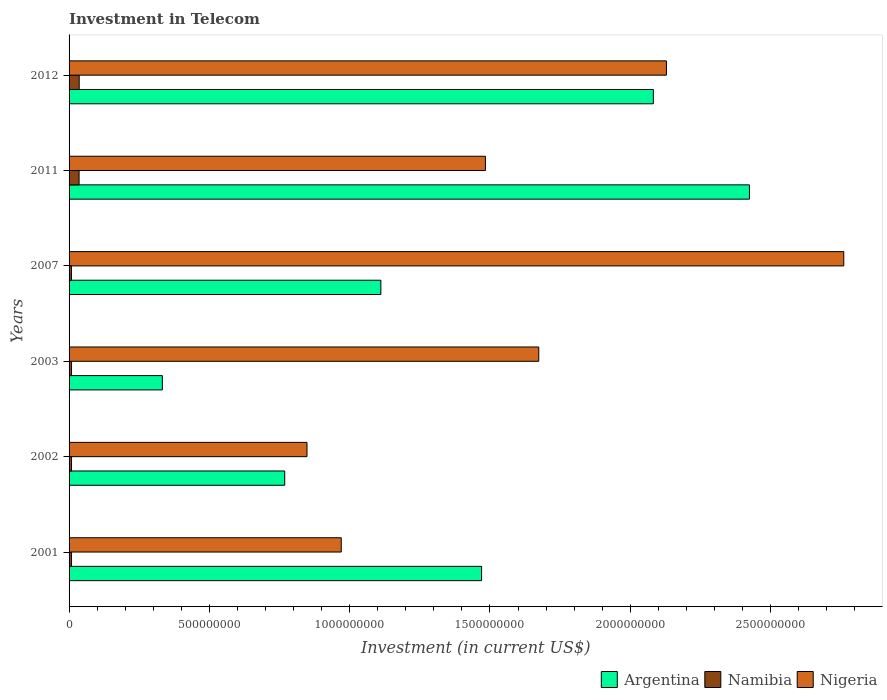How many groups of bars are there?
Ensure brevity in your answer.  6. How many bars are there on the 5th tick from the top?
Offer a very short reply. 3. What is the amount invested in telecom in Namibia in 2002?
Provide a short and direct response. 8.75e+06. Across all years, what is the maximum amount invested in telecom in Argentina?
Keep it short and to the point. 2.42e+09. Across all years, what is the minimum amount invested in telecom in Namibia?
Give a very brief answer. 8.50e+06. In which year was the amount invested in telecom in Nigeria minimum?
Ensure brevity in your answer.  2002. What is the total amount invested in telecom in Argentina in the graph?
Keep it short and to the point. 8.19e+09. What is the difference between the amount invested in telecom in Argentina in 2003 and that in 2007?
Give a very brief answer. -7.79e+08. What is the difference between the amount invested in telecom in Nigeria in 2011 and the amount invested in telecom in Namibia in 2001?
Ensure brevity in your answer.  1.48e+09. What is the average amount invested in telecom in Nigeria per year?
Your answer should be compact. 1.64e+09. In the year 2002, what is the difference between the amount invested in telecom in Argentina and amount invested in telecom in Namibia?
Make the answer very short. 7.60e+08. What is the ratio of the amount invested in telecom in Argentina in 2001 to that in 2012?
Offer a very short reply. 0.71. Is the difference between the amount invested in telecom in Argentina in 2003 and 2012 greater than the difference between the amount invested in telecom in Namibia in 2003 and 2012?
Offer a terse response. No. What is the difference between the highest and the second highest amount invested in telecom in Namibia?
Provide a succinct answer. 4.00e+05. What is the difference between the highest and the lowest amount invested in telecom in Namibia?
Your answer should be very brief. 2.76e+07. In how many years, is the amount invested in telecom in Nigeria greater than the average amount invested in telecom in Nigeria taken over all years?
Give a very brief answer. 3. Is the sum of the amount invested in telecom in Nigeria in 2001 and 2007 greater than the maximum amount invested in telecom in Namibia across all years?
Your answer should be compact. Yes. What does the 2nd bar from the top in 2012 represents?
Make the answer very short. Namibia. Are all the bars in the graph horizontal?
Your response must be concise. Yes. How many years are there in the graph?
Make the answer very short. 6. Does the graph contain grids?
Offer a terse response. No. How many legend labels are there?
Keep it short and to the point. 3. How are the legend labels stacked?
Your answer should be compact. Horizontal. What is the title of the graph?
Your answer should be compact. Investment in Telecom. What is the label or title of the X-axis?
Offer a very short reply. Investment (in current US$). What is the label or title of the Y-axis?
Ensure brevity in your answer.  Years. What is the Investment (in current US$) of Argentina in 2001?
Your answer should be compact. 1.47e+09. What is the Investment (in current US$) in Namibia in 2001?
Offer a very short reply. 8.75e+06. What is the Investment (in current US$) in Nigeria in 2001?
Provide a succinct answer. 9.70e+08. What is the Investment (in current US$) of Argentina in 2002?
Provide a short and direct response. 7.69e+08. What is the Investment (in current US$) in Namibia in 2002?
Your answer should be very brief. 8.75e+06. What is the Investment (in current US$) of Nigeria in 2002?
Your answer should be compact. 8.48e+08. What is the Investment (in current US$) of Argentina in 2003?
Provide a succinct answer. 3.32e+08. What is the Investment (in current US$) of Namibia in 2003?
Ensure brevity in your answer.  8.75e+06. What is the Investment (in current US$) in Nigeria in 2003?
Offer a terse response. 1.67e+09. What is the Investment (in current US$) of Argentina in 2007?
Keep it short and to the point. 1.11e+09. What is the Investment (in current US$) of Namibia in 2007?
Offer a terse response. 8.50e+06. What is the Investment (in current US$) of Nigeria in 2007?
Make the answer very short. 2.76e+09. What is the Investment (in current US$) of Argentina in 2011?
Your response must be concise. 2.42e+09. What is the Investment (in current US$) of Namibia in 2011?
Keep it short and to the point. 3.57e+07. What is the Investment (in current US$) in Nigeria in 2011?
Provide a short and direct response. 1.48e+09. What is the Investment (in current US$) in Argentina in 2012?
Make the answer very short. 2.08e+09. What is the Investment (in current US$) of Namibia in 2012?
Make the answer very short. 3.61e+07. What is the Investment (in current US$) of Nigeria in 2012?
Keep it short and to the point. 2.13e+09. Across all years, what is the maximum Investment (in current US$) in Argentina?
Make the answer very short. 2.42e+09. Across all years, what is the maximum Investment (in current US$) of Namibia?
Offer a terse response. 3.61e+07. Across all years, what is the maximum Investment (in current US$) in Nigeria?
Keep it short and to the point. 2.76e+09. Across all years, what is the minimum Investment (in current US$) in Argentina?
Provide a short and direct response. 3.32e+08. Across all years, what is the minimum Investment (in current US$) of Namibia?
Your response must be concise. 8.50e+06. Across all years, what is the minimum Investment (in current US$) in Nigeria?
Provide a short and direct response. 8.48e+08. What is the total Investment (in current US$) of Argentina in the graph?
Your response must be concise. 8.19e+09. What is the total Investment (in current US$) of Namibia in the graph?
Make the answer very short. 1.07e+08. What is the total Investment (in current US$) in Nigeria in the graph?
Your answer should be very brief. 9.87e+09. What is the difference between the Investment (in current US$) in Argentina in 2001 and that in 2002?
Ensure brevity in your answer.  7.02e+08. What is the difference between the Investment (in current US$) in Namibia in 2001 and that in 2002?
Ensure brevity in your answer.  0. What is the difference between the Investment (in current US$) of Nigeria in 2001 and that in 2002?
Your answer should be compact. 1.22e+08. What is the difference between the Investment (in current US$) of Argentina in 2001 and that in 2003?
Offer a very short reply. 1.14e+09. What is the difference between the Investment (in current US$) of Namibia in 2001 and that in 2003?
Give a very brief answer. 0. What is the difference between the Investment (in current US$) of Nigeria in 2001 and that in 2003?
Your response must be concise. -7.04e+08. What is the difference between the Investment (in current US$) in Argentina in 2001 and that in 2007?
Offer a terse response. 3.59e+08. What is the difference between the Investment (in current US$) in Nigeria in 2001 and that in 2007?
Your response must be concise. -1.79e+09. What is the difference between the Investment (in current US$) in Argentina in 2001 and that in 2011?
Provide a short and direct response. -9.55e+08. What is the difference between the Investment (in current US$) of Namibia in 2001 and that in 2011?
Provide a succinct answer. -2.70e+07. What is the difference between the Investment (in current US$) of Nigeria in 2001 and that in 2011?
Provide a succinct answer. -5.14e+08. What is the difference between the Investment (in current US$) in Argentina in 2001 and that in 2012?
Provide a succinct answer. -6.12e+08. What is the difference between the Investment (in current US$) of Namibia in 2001 and that in 2012?
Make the answer very short. -2.74e+07. What is the difference between the Investment (in current US$) in Nigeria in 2001 and that in 2012?
Keep it short and to the point. -1.16e+09. What is the difference between the Investment (in current US$) in Argentina in 2002 and that in 2003?
Offer a very short reply. 4.36e+08. What is the difference between the Investment (in current US$) of Nigeria in 2002 and that in 2003?
Your response must be concise. -8.26e+08. What is the difference between the Investment (in current US$) of Argentina in 2002 and that in 2007?
Your answer should be compact. -3.43e+08. What is the difference between the Investment (in current US$) in Namibia in 2002 and that in 2007?
Keep it short and to the point. 2.50e+05. What is the difference between the Investment (in current US$) of Nigeria in 2002 and that in 2007?
Provide a short and direct response. -1.91e+09. What is the difference between the Investment (in current US$) of Argentina in 2002 and that in 2011?
Offer a terse response. -1.66e+09. What is the difference between the Investment (in current US$) in Namibia in 2002 and that in 2011?
Make the answer very short. -2.70e+07. What is the difference between the Investment (in current US$) of Nigeria in 2002 and that in 2011?
Provide a succinct answer. -6.36e+08. What is the difference between the Investment (in current US$) of Argentina in 2002 and that in 2012?
Give a very brief answer. -1.31e+09. What is the difference between the Investment (in current US$) of Namibia in 2002 and that in 2012?
Offer a terse response. -2.74e+07. What is the difference between the Investment (in current US$) in Nigeria in 2002 and that in 2012?
Ensure brevity in your answer.  -1.28e+09. What is the difference between the Investment (in current US$) of Argentina in 2003 and that in 2007?
Offer a very short reply. -7.79e+08. What is the difference between the Investment (in current US$) of Nigeria in 2003 and that in 2007?
Provide a succinct answer. -1.09e+09. What is the difference between the Investment (in current US$) of Argentina in 2003 and that in 2011?
Ensure brevity in your answer.  -2.09e+09. What is the difference between the Investment (in current US$) in Namibia in 2003 and that in 2011?
Keep it short and to the point. -2.70e+07. What is the difference between the Investment (in current US$) of Nigeria in 2003 and that in 2011?
Keep it short and to the point. 1.90e+08. What is the difference between the Investment (in current US$) of Argentina in 2003 and that in 2012?
Your answer should be very brief. -1.75e+09. What is the difference between the Investment (in current US$) in Namibia in 2003 and that in 2012?
Your response must be concise. -2.74e+07. What is the difference between the Investment (in current US$) in Nigeria in 2003 and that in 2012?
Keep it short and to the point. -4.55e+08. What is the difference between the Investment (in current US$) of Argentina in 2007 and that in 2011?
Give a very brief answer. -1.31e+09. What is the difference between the Investment (in current US$) of Namibia in 2007 and that in 2011?
Provide a short and direct response. -2.72e+07. What is the difference between the Investment (in current US$) in Nigeria in 2007 and that in 2011?
Your response must be concise. 1.28e+09. What is the difference between the Investment (in current US$) in Argentina in 2007 and that in 2012?
Make the answer very short. -9.71e+08. What is the difference between the Investment (in current US$) of Namibia in 2007 and that in 2012?
Give a very brief answer. -2.76e+07. What is the difference between the Investment (in current US$) in Nigeria in 2007 and that in 2012?
Make the answer very short. 6.32e+08. What is the difference between the Investment (in current US$) of Argentina in 2011 and that in 2012?
Provide a short and direct response. 3.42e+08. What is the difference between the Investment (in current US$) of Namibia in 2011 and that in 2012?
Your answer should be compact. -4.00e+05. What is the difference between the Investment (in current US$) of Nigeria in 2011 and that in 2012?
Give a very brief answer. -6.45e+08. What is the difference between the Investment (in current US$) of Argentina in 2001 and the Investment (in current US$) of Namibia in 2002?
Your answer should be very brief. 1.46e+09. What is the difference between the Investment (in current US$) in Argentina in 2001 and the Investment (in current US$) in Nigeria in 2002?
Ensure brevity in your answer.  6.22e+08. What is the difference between the Investment (in current US$) of Namibia in 2001 and the Investment (in current US$) of Nigeria in 2002?
Provide a succinct answer. -8.39e+08. What is the difference between the Investment (in current US$) in Argentina in 2001 and the Investment (in current US$) in Namibia in 2003?
Your response must be concise. 1.46e+09. What is the difference between the Investment (in current US$) in Argentina in 2001 and the Investment (in current US$) in Nigeria in 2003?
Offer a terse response. -2.04e+08. What is the difference between the Investment (in current US$) of Namibia in 2001 and the Investment (in current US$) of Nigeria in 2003?
Keep it short and to the point. -1.67e+09. What is the difference between the Investment (in current US$) of Argentina in 2001 and the Investment (in current US$) of Namibia in 2007?
Provide a succinct answer. 1.46e+09. What is the difference between the Investment (in current US$) in Argentina in 2001 and the Investment (in current US$) in Nigeria in 2007?
Your response must be concise. -1.29e+09. What is the difference between the Investment (in current US$) in Namibia in 2001 and the Investment (in current US$) in Nigeria in 2007?
Provide a short and direct response. -2.75e+09. What is the difference between the Investment (in current US$) of Argentina in 2001 and the Investment (in current US$) of Namibia in 2011?
Provide a succinct answer. 1.43e+09. What is the difference between the Investment (in current US$) in Argentina in 2001 and the Investment (in current US$) in Nigeria in 2011?
Provide a short and direct response. -1.36e+07. What is the difference between the Investment (in current US$) in Namibia in 2001 and the Investment (in current US$) in Nigeria in 2011?
Your response must be concise. -1.48e+09. What is the difference between the Investment (in current US$) of Argentina in 2001 and the Investment (in current US$) of Namibia in 2012?
Ensure brevity in your answer.  1.43e+09. What is the difference between the Investment (in current US$) in Argentina in 2001 and the Investment (in current US$) in Nigeria in 2012?
Keep it short and to the point. -6.59e+08. What is the difference between the Investment (in current US$) of Namibia in 2001 and the Investment (in current US$) of Nigeria in 2012?
Offer a very short reply. -2.12e+09. What is the difference between the Investment (in current US$) of Argentina in 2002 and the Investment (in current US$) of Namibia in 2003?
Your answer should be compact. 7.60e+08. What is the difference between the Investment (in current US$) of Argentina in 2002 and the Investment (in current US$) of Nigeria in 2003?
Give a very brief answer. -9.05e+08. What is the difference between the Investment (in current US$) in Namibia in 2002 and the Investment (in current US$) in Nigeria in 2003?
Provide a succinct answer. -1.67e+09. What is the difference between the Investment (in current US$) in Argentina in 2002 and the Investment (in current US$) in Namibia in 2007?
Your response must be concise. 7.60e+08. What is the difference between the Investment (in current US$) of Argentina in 2002 and the Investment (in current US$) of Nigeria in 2007?
Offer a terse response. -1.99e+09. What is the difference between the Investment (in current US$) in Namibia in 2002 and the Investment (in current US$) in Nigeria in 2007?
Keep it short and to the point. -2.75e+09. What is the difference between the Investment (in current US$) of Argentina in 2002 and the Investment (in current US$) of Namibia in 2011?
Provide a short and direct response. 7.33e+08. What is the difference between the Investment (in current US$) in Argentina in 2002 and the Investment (in current US$) in Nigeria in 2011?
Provide a short and direct response. -7.15e+08. What is the difference between the Investment (in current US$) of Namibia in 2002 and the Investment (in current US$) of Nigeria in 2011?
Give a very brief answer. -1.48e+09. What is the difference between the Investment (in current US$) of Argentina in 2002 and the Investment (in current US$) of Namibia in 2012?
Your answer should be compact. 7.32e+08. What is the difference between the Investment (in current US$) of Argentina in 2002 and the Investment (in current US$) of Nigeria in 2012?
Provide a short and direct response. -1.36e+09. What is the difference between the Investment (in current US$) of Namibia in 2002 and the Investment (in current US$) of Nigeria in 2012?
Offer a terse response. -2.12e+09. What is the difference between the Investment (in current US$) of Argentina in 2003 and the Investment (in current US$) of Namibia in 2007?
Give a very brief answer. 3.24e+08. What is the difference between the Investment (in current US$) in Argentina in 2003 and the Investment (in current US$) in Nigeria in 2007?
Offer a terse response. -2.43e+09. What is the difference between the Investment (in current US$) of Namibia in 2003 and the Investment (in current US$) of Nigeria in 2007?
Keep it short and to the point. -2.75e+09. What is the difference between the Investment (in current US$) in Argentina in 2003 and the Investment (in current US$) in Namibia in 2011?
Keep it short and to the point. 2.97e+08. What is the difference between the Investment (in current US$) in Argentina in 2003 and the Investment (in current US$) in Nigeria in 2011?
Provide a short and direct response. -1.15e+09. What is the difference between the Investment (in current US$) of Namibia in 2003 and the Investment (in current US$) of Nigeria in 2011?
Give a very brief answer. -1.48e+09. What is the difference between the Investment (in current US$) in Argentina in 2003 and the Investment (in current US$) in Namibia in 2012?
Your answer should be very brief. 2.96e+08. What is the difference between the Investment (in current US$) of Argentina in 2003 and the Investment (in current US$) of Nigeria in 2012?
Make the answer very short. -1.80e+09. What is the difference between the Investment (in current US$) in Namibia in 2003 and the Investment (in current US$) in Nigeria in 2012?
Provide a succinct answer. -2.12e+09. What is the difference between the Investment (in current US$) in Argentina in 2007 and the Investment (in current US$) in Namibia in 2011?
Offer a very short reply. 1.08e+09. What is the difference between the Investment (in current US$) of Argentina in 2007 and the Investment (in current US$) of Nigeria in 2011?
Give a very brief answer. -3.73e+08. What is the difference between the Investment (in current US$) in Namibia in 2007 and the Investment (in current US$) in Nigeria in 2011?
Your answer should be compact. -1.48e+09. What is the difference between the Investment (in current US$) of Argentina in 2007 and the Investment (in current US$) of Namibia in 2012?
Ensure brevity in your answer.  1.08e+09. What is the difference between the Investment (in current US$) of Argentina in 2007 and the Investment (in current US$) of Nigeria in 2012?
Offer a very short reply. -1.02e+09. What is the difference between the Investment (in current US$) in Namibia in 2007 and the Investment (in current US$) in Nigeria in 2012?
Your answer should be very brief. -2.12e+09. What is the difference between the Investment (in current US$) in Argentina in 2011 and the Investment (in current US$) in Namibia in 2012?
Provide a short and direct response. 2.39e+09. What is the difference between the Investment (in current US$) of Argentina in 2011 and the Investment (in current US$) of Nigeria in 2012?
Give a very brief answer. 2.96e+08. What is the difference between the Investment (in current US$) of Namibia in 2011 and the Investment (in current US$) of Nigeria in 2012?
Your answer should be compact. -2.09e+09. What is the average Investment (in current US$) in Argentina per year?
Provide a short and direct response. 1.36e+09. What is the average Investment (in current US$) in Namibia per year?
Make the answer very short. 1.78e+07. What is the average Investment (in current US$) in Nigeria per year?
Provide a short and direct response. 1.64e+09. In the year 2001, what is the difference between the Investment (in current US$) of Argentina and Investment (in current US$) of Namibia?
Offer a terse response. 1.46e+09. In the year 2001, what is the difference between the Investment (in current US$) of Argentina and Investment (in current US$) of Nigeria?
Ensure brevity in your answer.  5.00e+08. In the year 2001, what is the difference between the Investment (in current US$) in Namibia and Investment (in current US$) in Nigeria?
Ensure brevity in your answer.  -9.61e+08. In the year 2002, what is the difference between the Investment (in current US$) in Argentina and Investment (in current US$) in Namibia?
Your response must be concise. 7.60e+08. In the year 2002, what is the difference between the Investment (in current US$) in Argentina and Investment (in current US$) in Nigeria?
Keep it short and to the point. -7.94e+07. In the year 2002, what is the difference between the Investment (in current US$) of Namibia and Investment (in current US$) of Nigeria?
Offer a very short reply. -8.39e+08. In the year 2003, what is the difference between the Investment (in current US$) in Argentina and Investment (in current US$) in Namibia?
Ensure brevity in your answer.  3.24e+08. In the year 2003, what is the difference between the Investment (in current US$) in Argentina and Investment (in current US$) in Nigeria?
Keep it short and to the point. -1.34e+09. In the year 2003, what is the difference between the Investment (in current US$) of Namibia and Investment (in current US$) of Nigeria?
Your answer should be compact. -1.67e+09. In the year 2007, what is the difference between the Investment (in current US$) of Argentina and Investment (in current US$) of Namibia?
Keep it short and to the point. 1.10e+09. In the year 2007, what is the difference between the Investment (in current US$) of Argentina and Investment (in current US$) of Nigeria?
Your response must be concise. -1.65e+09. In the year 2007, what is the difference between the Investment (in current US$) in Namibia and Investment (in current US$) in Nigeria?
Offer a terse response. -2.75e+09. In the year 2011, what is the difference between the Investment (in current US$) in Argentina and Investment (in current US$) in Namibia?
Ensure brevity in your answer.  2.39e+09. In the year 2011, what is the difference between the Investment (in current US$) of Argentina and Investment (in current US$) of Nigeria?
Ensure brevity in your answer.  9.41e+08. In the year 2011, what is the difference between the Investment (in current US$) of Namibia and Investment (in current US$) of Nigeria?
Your answer should be very brief. -1.45e+09. In the year 2012, what is the difference between the Investment (in current US$) in Argentina and Investment (in current US$) in Namibia?
Give a very brief answer. 2.05e+09. In the year 2012, what is the difference between the Investment (in current US$) in Argentina and Investment (in current US$) in Nigeria?
Offer a very short reply. -4.66e+07. In the year 2012, what is the difference between the Investment (in current US$) of Namibia and Investment (in current US$) of Nigeria?
Your answer should be very brief. -2.09e+09. What is the ratio of the Investment (in current US$) of Argentina in 2001 to that in 2002?
Keep it short and to the point. 1.91. What is the ratio of the Investment (in current US$) of Namibia in 2001 to that in 2002?
Ensure brevity in your answer.  1. What is the ratio of the Investment (in current US$) of Nigeria in 2001 to that in 2002?
Make the answer very short. 1.14. What is the ratio of the Investment (in current US$) of Argentina in 2001 to that in 2003?
Your answer should be very brief. 4.42. What is the ratio of the Investment (in current US$) in Namibia in 2001 to that in 2003?
Offer a terse response. 1. What is the ratio of the Investment (in current US$) of Nigeria in 2001 to that in 2003?
Make the answer very short. 0.58. What is the ratio of the Investment (in current US$) of Argentina in 2001 to that in 2007?
Provide a succinct answer. 1.32. What is the ratio of the Investment (in current US$) of Namibia in 2001 to that in 2007?
Give a very brief answer. 1.03. What is the ratio of the Investment (in current US$) of Nigeria in 2001 to that in 2007?
Keep it short and to the point. 0.35. What is the ratio of the Investment (in current US$) in Argentina in 2001 to that in 2011?
Keep it short and to the point. 0.61. What is the ratio of the Investment (in current US$) of Namibia in 2001 to that in 2011?
Offer a very short reply. 0.25. What is the ratio of the Investment (in current US$) of Nigeria in 2001 to that in 2011?
Provide a succinct answer. 0.65. What is the ratio of the Investment (in current US$) in Argentina in 2001 to that in 2012?
Ensure brevity in your answer.  0.71. What is the ratio of the Investment (in current US$) of Namibia in 2001 to that in 2012?
Make the answer very short. 0.24. What is the ratio of the Investment (in current US$) in Nigeria in 2001 to that in 2012?
Your response must be concise. 0.46. What is the ratio of the Investment (in current US$) of Argentina in 2002 to that in 2003?
Your answer should be compact. 2.31. What is the ratio of the Investment (in current US$) of Namibia in 2002 to that in 2003?
Give a very brief answer. 1. What is the ratio of the Investment (in current US$) in Nigeria in 2002 to that in 2003?
Keep it short and to the point. 0.51. What is the ratio of the Investment (in current US$) of Argentina in 2002 to that in 2007?
Your answer should be compact. 0.69. What is the ratio of the Investment (in current US$) of Namibia in 2002 to that in 2007?
Give a very brief answer. 1.03. What is the ratio of the Investment (in current US$) in Nigeria in 2002 to that in 2007?
Your response must be concise. 0.31. What is the ratio of the Investment (in current US$) of Argentina in 2002 to that in 2011?
Give a very brief answer. 0.32. What is the ratio of the Investment (in current US$) in Namibia in 2002 to that in 2011?
Your response must be concise. 0.25. What is the ratio of the Investment (in current US$) in Nigeria in 2002 to that in 2011?
Provide a succinct answer. 0.57. What is the ratio of the Investment (in current US$) in Argentina in 2002 to that in 2012?
Offer a terse response. 0.37. What is the ratio of the Investment (in current US$) of Namibia in 2002 to that in 2012?
Offer a very short reply. 0.24. What is the ratio of the Investment (in current US$) of Nigeria in 2002 to that in 2012?
Offer a very short reply. 0.4. What is the ratio of the Investment (in current US$) of Argentina in 2003 to that in 2007?
Provide a short and direct response. 0.3. What is the ratio of the Investment (in current US$) in Namibia in 2003 to that in 2007?
Provide a succinct answer. 1.03. What is the ratio of the Investment (in current US$) of Nigeria in 2003 to that in 2007?
Ensure brevity in your answer.  0.61. What is the ratio of the Investment (in current US$) of Argentina in 2003 to that in 2011?
Give a very brief answer. 0.14. What is the ratio of the Investment (in current US$) of Namibia in 2003 to that in 2011?
Ensure brevity in your answer.  0.25. What is the ratio of the Investment (in current US$) of Nigeria in 2003 to that in 2011?
Offer a terse response. 1.13. What is the ratio of the Investment (in current US$) of Argentina in 2003 to that in 2012?
Ensure brevity in your answer.  0.16. What is the ratio of the Investment (in current US$) of Namibia in 2003 to that in 2012?
Your answer should be compact. 0.24. What is the ratio of the Investment (in current US$) in Nigeria in 2003 to that in 2012?
Keep it short and to the point. 0.79. What is the ratio of the Investment (in current US$) in Argentina in 2007 to that in 2011?
Ensure brevity in your answer.  0.46. What is the ratio of the Investment (in current US$) of Namibia in 2007 to that in 2011?
Your answer should be very brief. 0.24. What is the ratio of the Investment (in current US$) in Nigeria in 2007 to that in 2011?
Keep it short and to the point. 1.86. What is the ratio of the Investment (in current US$) of Argentina in 2007 to that in 2012?
Give a very brief answer. 0.53. What is the ratio of the Investment (in current US$) in Namibia in 2007 to that in 2012?
Your response must be concise. 0.24. What is the ratio of the Investment (in current US$) of Nigeria in 2007 to that in 2012?
Your response must be concise. 1.3. What is the ratio of the Investment (in current US$) of Argentina in 2011 to that in 2012?
Keep it short and to the point. 1.16. What is the ratio of the Investment (in current US$) of Namibia in 2011 to that in 2012?
Ensure brevity in your answer.  0.99. What is the ratio of the Investment (in current US$) in Nigeria in 2011 to that in 2012?
Your answer should be very brief. 0.7. What is the difference between the highest and the second highest Investment (in current US$) of Argentina?
Ensure brevity in your answer.  3.42e+08. What is the difference between the highest and the second highest Investment (in current US$) of Namibia?
Give a very brief answer. 4.00e+05. What is the difference between the highest and the second highest Investment (in current US$) in Nigeria?
Your answer should be very brief. 6.32e+08. What is the difference between the highest and the lowest Investment (in current US$) in Argentina?
Offer a very short reply. 2.09e+09. What is the difference between the highest and the lowest Investment (in current US$) in Namibia?
Your response must be concise. 2.76e+07. What is the difference between the highest and the lowest Investment (in current US$) of Nigeria?
Provide a succinct answer. 1.91e+09. 